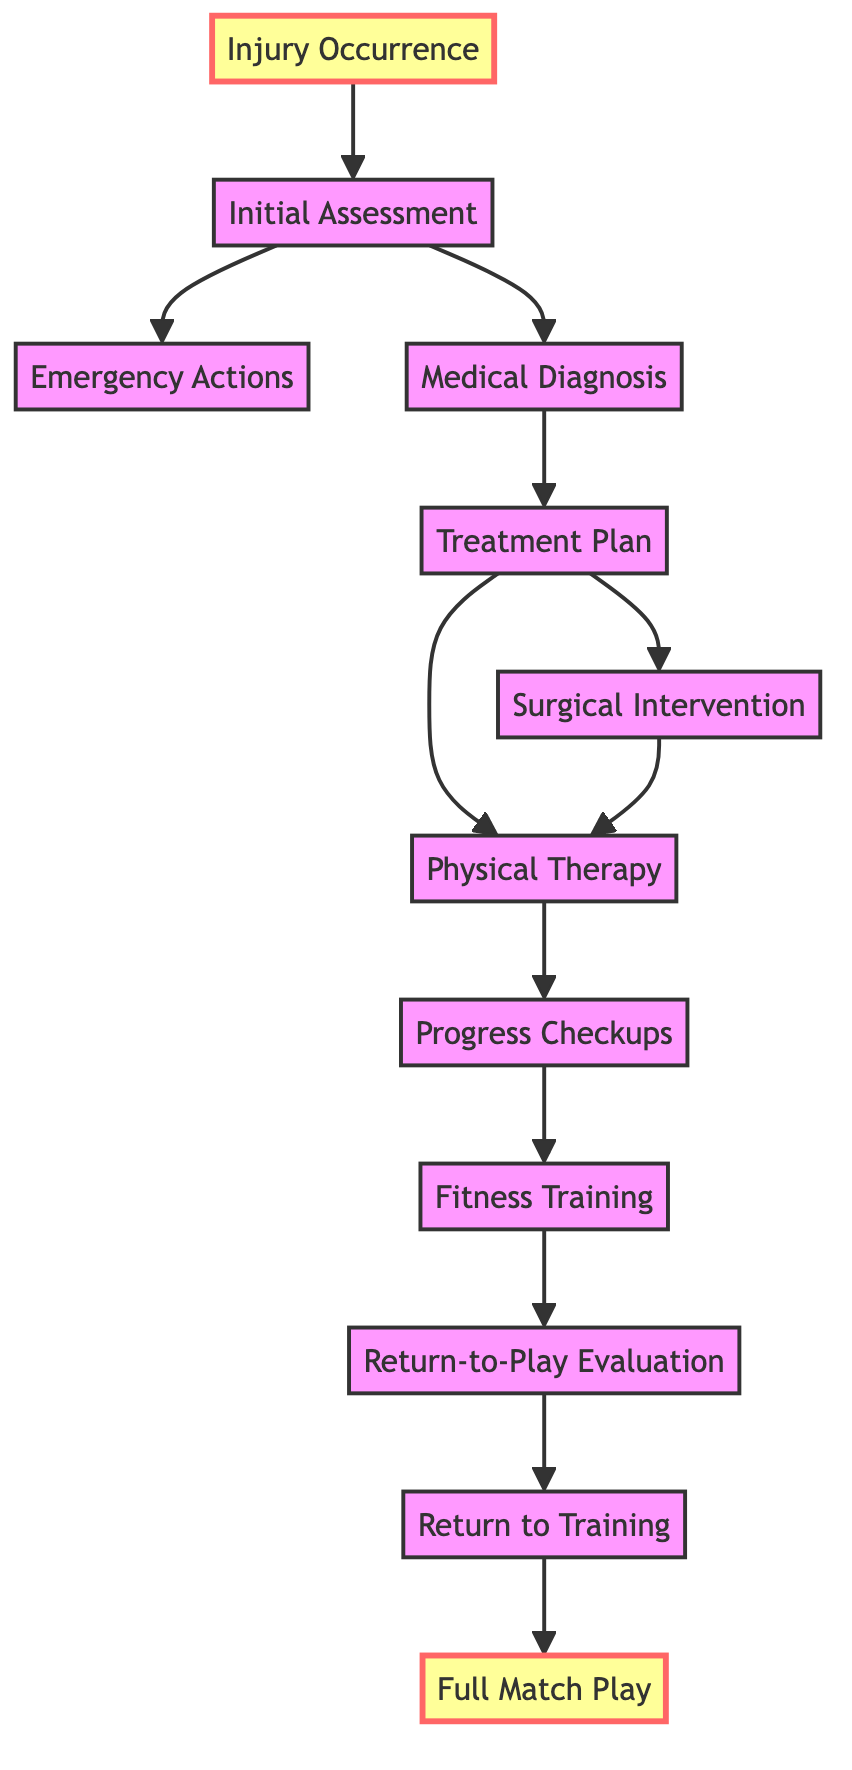What is the first stage after the injury occurrence? According to the directed graph, the first stage following injury occurrence is the initial assessment, which is represented as a direct connection from injury occurrence to initial assessment.
Answer: Initial Assessment How many total stages are in the injury recovery process? By counting all the unique nodes in the directed graph, there are a total of 12 stages in the injury recovery process from injury occurrence to full match play.
Answer: 12 What follows the medical diagnosis in the recovery process? The directed graph shows that after medical diagnosis, the next stage is the treatment plan, as indicated by the directed edge connecting medical diagnosis to treatment plan.
Answer: Treatment Plan Which medical action can occur after the treatment plan? From the treatment plan, two branches are available: one can lead to surgical intervention and the other to physical therapy, so both actions can occur after the treatment plan depending on the specific case.
Answer: Surgical Intervention, Physical Therapy Is there a direct connection between progress checkups and fitness training? Yes, there is a directed edge from progress checkups to fitness training, indicating that fitness training comes after progress checkups.
Answer: Yes What stage must occur before the return to training? The directed graph illustrates that the return-to-play evaluation must occur before the player can return to training, showing a direct relationship between the two stages.
Answer: Return-to-Play Evaluation How many direct interventions can result from the treatment plan? The treatment plan can lead to two direct interventions: surgical intervention and physical therapy, which indicates the options available after this stage.
Answer: 2 What is the endpoint of the recovery process represented in this diagram? The endpoint of the recovery process is represented by the full match play, which is reached after successfully completing the previous stages leading up to it.
Answer: Full Match Play What type of assessment follows the physical therapy stage in this recovery diagram? The directed graph indicates that the next assessment following physical therapy is progress checkups, which are scheduled to monitor recovery progress.
Answer: Progress Checkups 